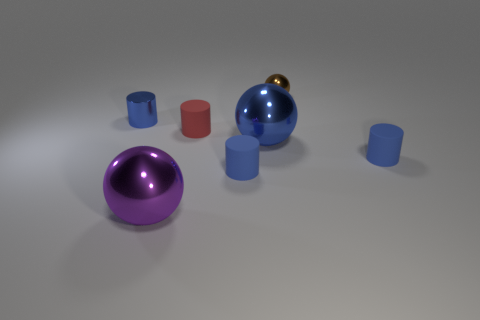There is a blue metal object right of the blue metallic cylinder; is its shape the same as the tiny brown metal object?
Give a very brief answer. Yes. What number of other objects are the same shape as the big blue metal thing?
Your answer should be very brief. 2. The tiny object that is on the right side of the brown metal sphere has what shape?
Provide a short and direct response. Cylinder. Are there any other spheres that have the same material as the tiny ball?
Offer a terse response. Yes. Do the big metal sphere that is behind the big purple metallic thing and the small metallic cylinder have the same color?
Provide a short and direct response. Yes. What is the size of the blue metal sphere?
Offer a terse response. Large. Are there any balls that are in front of the tiny metallic object on the right side of the purple object that is to the left of the red matte thing?
Your answer should be compact. Yes. What number of brown metallic things are behind the large purple ball?
Your response must be concise. 1. How many small metallic things have the same color as the small metallic cylinder?
Give a very brief answer. 0. What number of objects are shiny cylinders in front of the small brown metal thing or large things that are in front of the tiny brown thing?
Your answer should be very brief. 3. 